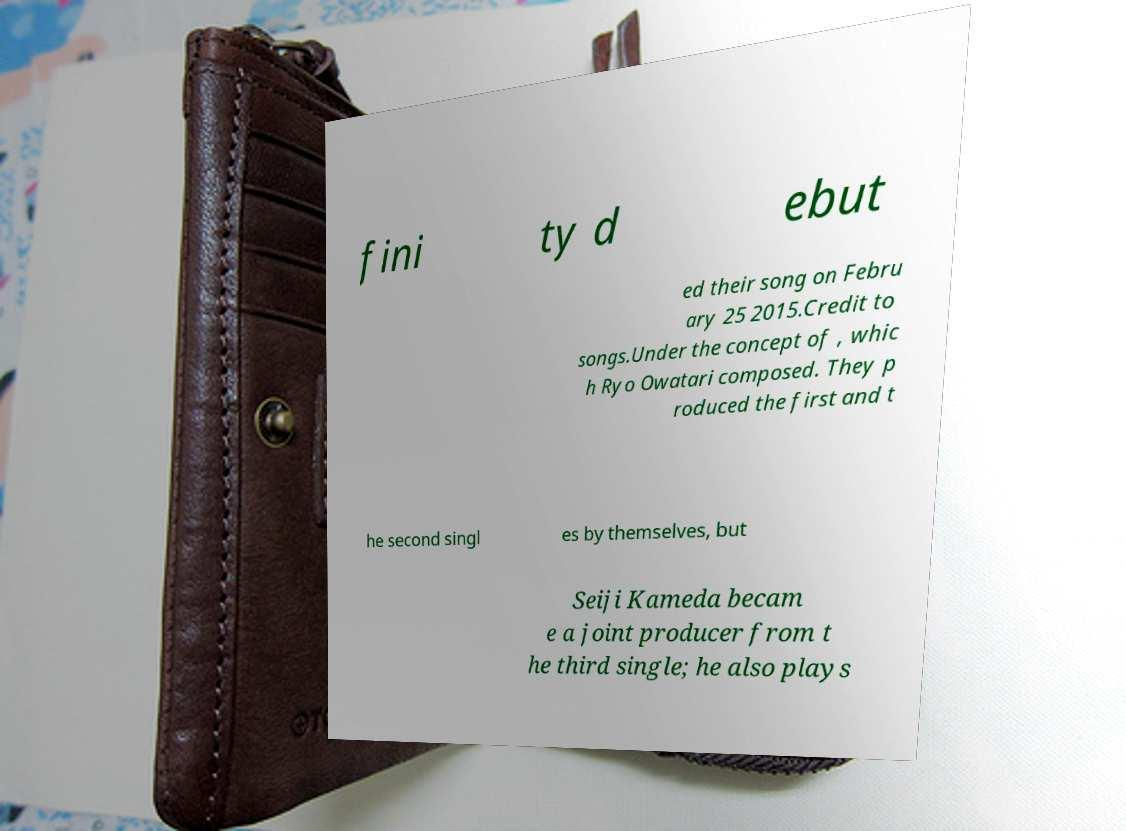For documentation purposes, I need the text within this image transcribed. Could you provide that? fini ty d ebut ed their song on Febru ary 25 2015.Credit to songs.Under the concept of , whic h Ryo Owatari composed. They p roduced the first and t he second singl es by themselves, but Seiji Kameda becam e a joint producer from t he third single; he also plays 